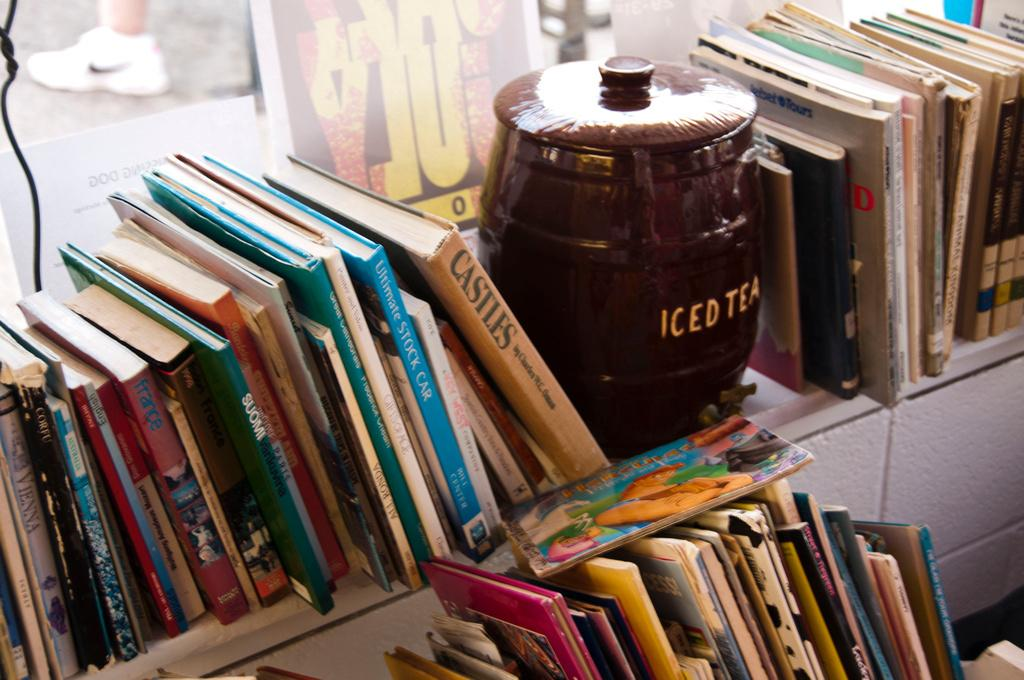<image>
Write a terse but informative summary of the picture. The product in the ceramic container is Iced Tea 